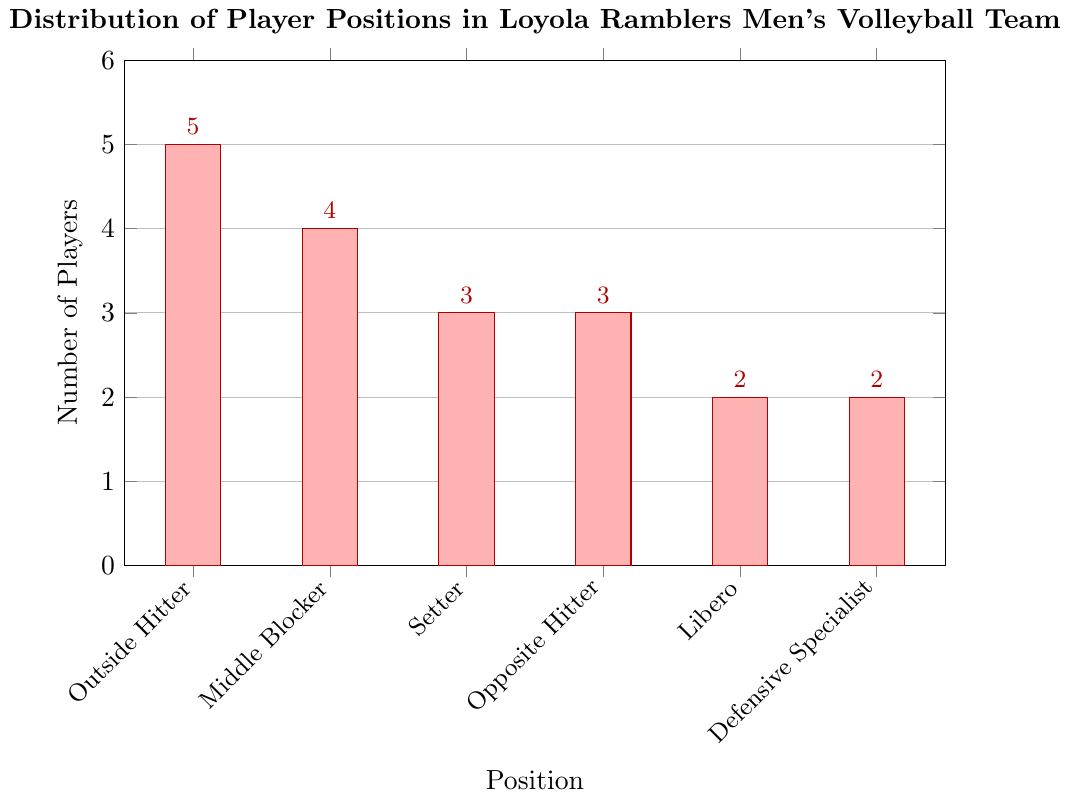How many more Outside Hitters are there compared to Liberos? To find this, look at the number of players in each position: Outside Hitters have 5 players and Liberos have 2. The difference is 5 - 2.
Answer: 3 How many players are there in total on the Loyola Ramblers men's volleyball team? Sum the number of players in each position: 5 (Outside Hitters) + 4 (Middle Blockers) + 3 (Setters) + 3 (Opposite Hitters) + 2 (Liberos) + 2 (Defensive Specialists).
Answer: 19 Which two positions have the same number of players? Check the bar heights and the numbers next to each bar: Setters and Opposite Hitters both have 3 players each.
Answer: Setters and Opposite Hitters What is the average number of players per position? Sum the number of players (19) and divide by the number of positions (6). The sum is 19, and dividing by 6 gives approximately 3.17.
Answer: 3.17 Is the number of Middle Blockers greater than the number of Setters? Compare the height of the bars for Middle Blockers and Setters. Middle Blockers have 4 players while Setters have 3.
Answer: Yes Which position has the fewest players? Find the shortest bar, which corresponds to the position with the fewest players. Both Libero and Defensive Specialist have the shortest bars with 2 players each.
Answer: Libero and Defensive Specialist By what percentage is the number of Outside Hitters greater than the number of Setters? First calculate the difference (5 - 3 = 2), then divide by the number of Setters and multiply by 100: (2 / 3) * 100 ≈ 66.67%.
Answer: 66.67% How many positions have more than 3 players? Count the positions where the bar height is above 3. Outside Hitters and Middle Blockers have more than 3 players.
Answer: 2 